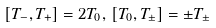Convert formula to latex. <formula><loc_0><loc_0><loc_500><loc_500>[ T _ { - } , T _ { + } ] = 2 T _ { 0 } , \, [ T _ { 0 } , T _ { \pm } ] = \pm T _ { \pm }</formula> 